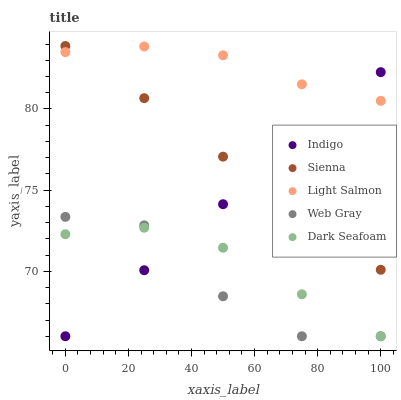Does Web Gray have the minimum area under the curve?
Answer yes or no. Yes. Does Light Salmon have the maximum area under the curve?
Answer yes or no. Yes. Does Light Salmon have the minimum area under the curve?
Answer yes or no. No. Does Web Gray have the maximum area under the curve?
Answer yes or no. No. Is Indigo the smoothest?
Answer yes or no. Yes. Is Web Gray the roughest?
Answer yes or no. Yes. Is Light Salmon the smoothest?
Answer yes or no. No. Is Light Salmon the roughest?
Answer yes or no. No. Does Web Gray have the lowest value?
Answer yes or no. Yes. Does Light Salmon have the lowest value?
Answer yes or no. No. Does Sienna have the highest value?
Answer yes or no. Yes. Does Light Salmon have the highest value?
Answer yes or no. No. Is Dark Seafoam less than Sienna?
Answer yes or no. Yes. Is Sienna greater than Web Gray?
Answer yes or no. Yes. Does Indigo intersect Light Salmon?
Answer yes or no. Yes. Is Indigo less than Light Salmon?
Answer yes or no. No. Is Indigo greater than Light Salmon?
Answer yes or no. No. Does Dark Seafoam intersect Sienna?
Answer yes or no. No. 